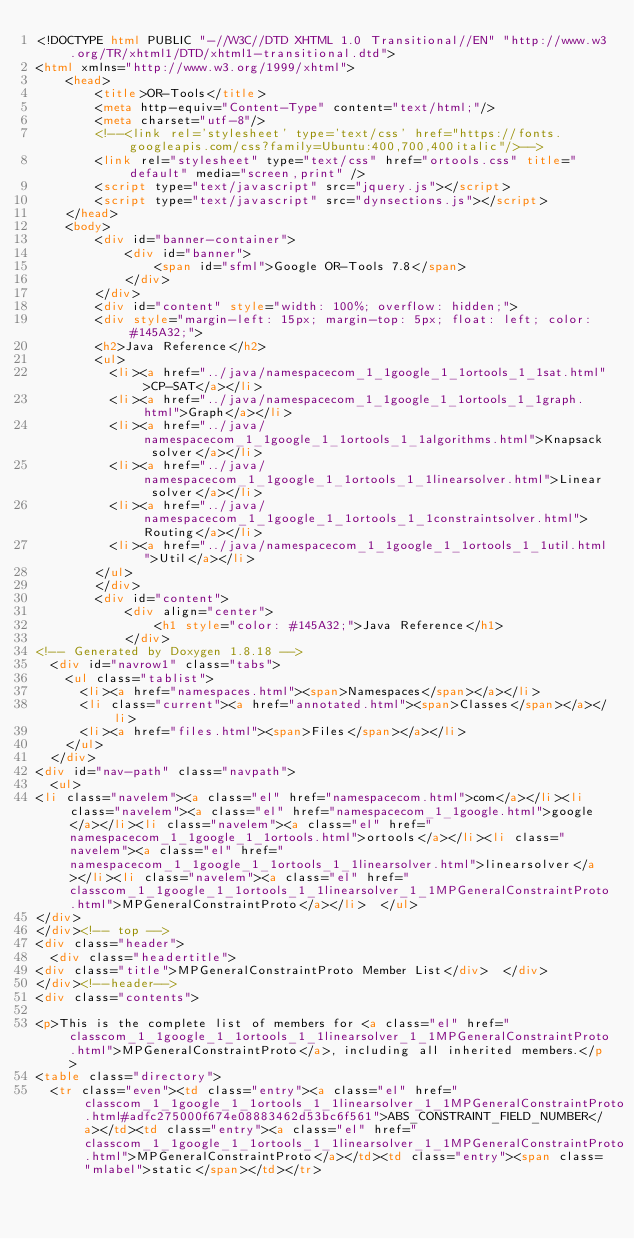<code> <loc_0><loc_0><loc_500><loc_500><_HTML_><!DOCTYPE html PUBLIC "-//W3C//DTD XHTML 1.0 Transitional//EN" "http://www.w3.org/TR/xhtml1/DTD/xhtml1-transitional.dtd">
<html xmlns="http://www.w3.org/1999/xhtml">
    <head>
        <title>OR-Tools</title>
        <meta http-equiv="Content-Type" content="text/html;"/>
        <meta charset="utf-8"/>
        <!--<link rel='stylesheet' type='text/css' href="https://fonts.googleapis.com/css?family=Ubuntu:400,700,400italic"/>-->
        <link rel="stylesheet" type="text/css" href="ortools.css" title="default" media="screen,print" />
        <script type="text/javascript" src="jquery.js"></script>
        <script type="text/javascript" src="dynsections.js"></script>
    </head>
    <body>
        <div id="banner-container">
            <div id="banner">
                <span id="sfml">Google OR-Tools 7.8</span>
            </div>
        </div>
        <div id="content" style="width: 100%; overflow: hidden;">
        <div style="margin-left: 15px; margin-top: 5px; float: left; color: #145A32;">
        <h2>Java Reference</h2>
        <ul>
          <li><a href="../java/namespacecom_1_1google_1_1ortools_1_1sat.html">CP-SAT</a></li>
          <li><a href="../java/namespacecom_1_1google_1_1ortools_1_1graph.html">Graph</a></li>
          <li><a href="../java/namespacecom_1_1google_1_1ortools_1_1algorithms.html">Knapsack solver</a></li>
          <li><a href="../java/namespacecom_1_1google_1_1ortools_1_1linearsolver.html">Linear solver</a></li>
          <li><a href="../java/namespacecom_1_1google_1_1ortools_1_1constraintsolver.html">Routing</a></li>
          <li><a href="../java/namespacecom_1_1google_1_1ortools_1_1util.html">Util</a></li>
        </ul>
        </div>
        <div id="content">
            <div align="center">
                <h1 style="color: #145A32;">Java Reference</h1>
            </div>
<!-- Generated by Doxygen 1.8.18 -->
  <div id="navrow1" class="tabs">
    <ul class="tablist">
      <li><a href="namespaces.html"><span>Namespaces</span></a></li>
      <li class="current"><a href="annotated.html"><span>Classes</span></a></li>
      <li><a href="files.html"><span>Files</span></a></li>
    </ul>
  </div>
<div id="nav-path" class="navpath">
  <ul>
<li class="navelem"><a class="el" href="namespacecom.html">com</a></li><li class="navelem"><a class="el" href="namespacecom_1_1google.html">google</a></li><li class="navelem"><a class="el" href="namespacecom_1_1google_1_1ortools.html">ortools</a></li><li class="navelem"><a class="el" href="namespacecom_1_1google_1_1ortools_1_1linearsolver.html">linearsolver</a></li><li class="navelem"><a class="el" href="classcom_1_1google_1_1ortools_1_1linearsolver_1_1MPGeneralConstraintProto.html">MPGeneralConstraintProto</a></li>  </ul>
</div>
</div><!-- top -->
<div class="header">
  <div class="headertitle">
<div class="title">MPGeneralConstraintProto Member List</div>  </div>
</div><!--header-->
<div class="contents">

<p>This is the complete list of members for <a class="el" href="classcom_1_1google_1_1ortools_1_1linearsolver_1_1MPGeneralConstraintProto.html">MPGeneralConstraintProto</a>, including all inherited members.</p>
<table class="directory">
  <tr class="even"><td class="entry"><a class="el" href="classcom_1_1google_1_1ortools_1_1linearsolver_1_1MPGeneralConstraintProto.html#adfc275000f674e08883462d53bc6f561">ABS_CONSTRAINT_FIELD_NUMBER</a></td><td class="entry"><a class="el" href="classcom_1_1google_1_1ortools_1_1linearsolver_1_1MPGeneralConstraintProto.html">MPGeneralConstraintProto</a></td><td class="entry"><span class="mlabel">static</span></td></tr></code> 